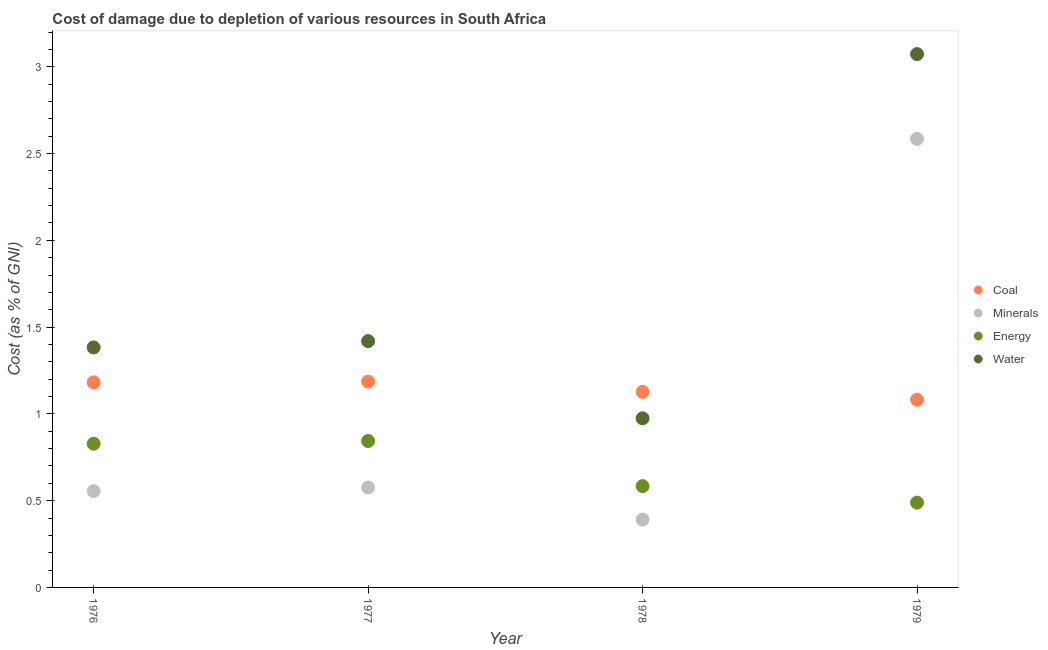Is the number of dotlines equal to the number of legend labels?
Provide a succinct answer. Yes. What is the cost of damage due to depletion of minerals in 1979?
Offer a very short reply. 2.58. Across all years, what is the maximum cost of damage due to depletion of energy?
Provide a succinct answer. 0.84. Across all years, what is the minimum cost of damage due to depletion of coal?
Provide a short and direct response. 1.08. In which year was the cost of damage due to depletion of coal maximum?
Make the answer very short. 1977. In which year was the cost of damage due to depletion of minerals minimum?
Your answer should be compact. 1978. What is the total cost of damage due to depletion of water in the graph?
Your response must be concise. 6.85. What is the difference between the cost of damage due to depletion of minerals in 1977 and that in 1978?
Your response must be concise. 0.18. What is the difference between the cost of damage due to depletion of coal in 1979 and the cost of damage due to depletion of minerals in 1977?
Your response must be concise. 0.51. What is the average cost of damage due to depletion of energy per year?
Provide a succinct answer. 0.69. In the year 1976, what is the difference between the cost of damage due to depletion of minerals and cost of damage due to depletion of coal?
Your answer should be very brief. -0.63. What is the ratio of the cost of damage due to depletion of minerals in 1976 to that in 1977?
Ensure brevity in your answer.  0.96. Is the cost of damage due to depletion of coal in 1978 less than that in 1979?
Provide a short and direct response. No. Is the difference between the cost of damage due to depletion of water in 1976 and 1977 greater than the difference between the cost of damage due to depletion of minerals in 1976 and 1977?
Offer a very short reply. No. What is the difference between the highest and the second highest cost of damage due to depletion of minerals?
Provide a succinct answer. 2.01. What is the difference between the highest and the lowest cost of damage due to depletion of water?
Keep it short and to the point. 2.1. In how many years, is the cost of damage due to depletion of water greater than the average cost of damage due to depletion of water taken over all years?
Provide a succinct answer. 1. Is it the case that in every year, the sum of the cost of damage due to depletion of minerals and cost of damage due to depletion of water is greater than the sum of cost of damage due to depletion of energy and cost of damage due to depletion of coal?
Give a very brief answer. Yes. Is it the case that in every year, the sum of the cost of damage due to depletion of coal and cost of damage due to depletion of minerals is greater than the cost of damage due to depletion of energy?
Provide a succinct answer. Yes. Does the cost of damage due to depletion of coal monotonically increase over the years?
Your answer should be very brief. No. Is the cost of damage due to depletion of coal strictly less than the cost of damage due to depletion of energy over the years?
Your response must be concise. No. How many dotlines are there?
Offer a very short reply. 4. Does the graph contain grids?
Provide a succinct answer. No. Where does the legend appear in the graph?
Offer a terse response. Center right. How many legend labels are there?
Your response must be concise. 4. What is the title of the graph?
Provide a succinct answer. Cost of damage due to depletion of various resources in South Africa . What is the label or title of the X-axis?
Provide a short and direct response. Year. What is the label or title of the Y-axis?
Give a very brief answer. Cost (as % of GNI). What is the Cost (as % of GNI) in Coal in 1976?
Your answer should be very brief. 1.18. What is the Cost (as % of GNI) of Minerals in 1976?
Keep it short and to the point. 0.55. What is the Cost (as % of GNI) in Energy in 1976?
Make the answer very short. 0.83. What is the Cost (as % of GNI) of Water in 1976?
Offer a terse response. 1.38. What is the Cost (as % of GNI) of Coal in 1977?
Give a very brief answer. 1.19. What is the Cost (as % of GNI) in Minerals in 1977?
Keep it short and to the point. 0.58. What is the Cost (as % of GNI) of Energy in 1977?
Keep it short and to the point. 0.84. What is the Cost (as % of GNI) in Water in 1977?
Ensure brevity in your answer.  1.42. What is the Cost (as % of GNI) in Coal in 1978?
Provide a short and direct response. 1.13. What is the Cost (as % of GNI) of Minerals in 1978?
Provide a succinct answer. 0.39. What is the Cost (as % of GNI) in Energy in 1978?
Provide a succinct answer. 0.58. What is the Cost (as % of GNI) of Water in 1978?
Your response must be concise. 0.97. What is the Cost (as % of GNI) in Coal in 1979?
Your answer should be compact. 1.08. What is the Cost (as % of GNI) of Minerals in 1979?
Provide a succinct answer. 2.58. What is the Cost (as % of GNI) in Energy in 1979?
Provide a succinct answer. 0.49. What is the Cost (as % of GNI) of Water in 1979?
Give a very brief answer. 3.07. Across all years, what is the maximum Cost (as % of GNI) of Coal?
Your answer should be very brief. 1.19. Across all years, what is the maximum Cost (as % of GNI) in Minerals?
Your answer should be very brief. 2.58. Across all years, what is the maximum Cost (as % of GNI) in Energy?
Offer a very short reply. 0.84. Across all years, what is the maximum Cost (as % of GNI) of Water?
Keep it short and to the point. 3.07. Across all years, what is the minimum Cost (as % of GNI) of Coal?
Your answer should be very brief. 1.08. Across all years, what is the minimum Cost (as % of GNI) of Minerals?
Offer a very short reply. 0.39. Across all years, what is the minimum Cost (as % of GNI) of Energy?
Provide a succinct answer. 0.49. Across all years, what is the minimum Cost (as % of GNI) in Water?
Ensure brevity in your answer.  0.97. What is the total Cost (as % of GNI) of Coal in the graph?
Your answer should be compact. 4.58. What is the total Cost (as % of GNI) in Minerals in the graph?
Offer a terse response. 4.11. What is the total Cost (as % of GNI) of Energy in the graph?
Provide a succinct answer. 2.74. What is the total Cost (as % of GNI) of Water in the graph?
Keep it short and to the point. 6.85. What is the difference between the Cost (as % of GNI) in Coal in 1976 and that in 1977?
Your response must be concise. -0. What is the difference between the Cost (as % of GNI) in Minerals in 1976 and that in 1977?
Offer a terse response. -0.02. What is the difference between the Cost (as % of GNI) of Energy in 1976 and that in 1977?
Your response must be concise. -0.02. What is the difference between the Cost (as % of GNI) of Water in 1976 and that in 1977?
Your answer should be compact. -0.04. What is the difference between the Cost (as % of GNI) of Coal in 1976 and that in 1978?
Offer a terse response. 0.05. What is the difference between the Cost (as % of GNI) in Minerals in 1976 and that in 1978?
Offer a very short reply. 0.16. What is the difference between the Cost (as % of GNI) of Energy in 1976 and that in 1978?
Provide a short and direct response. 0.24. What is the difference between the Cost (as % of GNI) of Water in 1976 and that in 1978?
Make the answer very short. 0.41. What is the difference between the Cost (as % of GNI) in Coal in 1976 and that in 1979?
Provide a short and direct response. 0.1. What is the difference between the Cost (as % of GNI) in Minerals in 1976 and that in 1979?
Offer a terse response. -2.03. What is the difference between the Cost (as % of GNI) of Energy in 1976 and that in 1979?
Provide a short and direct response. 0.34. What is the difference between the Cost (as % of GNI) of Water in 1976 and that in 1979?
Provide a short and direct response. -1.69. What is the difference between the Cost (as % of GNI) in Coal in 1977 and that in 1978?
Provide a short and direct response. 0.06. What is the difference between the Cost (as % of GNI) of Minerals in 1977 and that in 1978?
Offer a very short reply. 0.18. What is the difference between the Cost (as % of GNI) in Energy in 1977 and that in 1978?
Your answer should be very brief. 0.26. What is the difference between the Cost (as % of GNI) in Water in 1977 and that in 1978?
Your response must be concise. 0.44. What is the difference between the Cost (as % of GNI) in Coal in 1977 and that in 1979?
Ensure brevity in your answer.  0.1. What is the difference between the Cost (as % of GNI) of Minerals in 1977 and that in 1979?
Your answer should be compact. -2.01. What is the difference between the Cost (as % of GNI) in Energy in 1977 and that in 1979?
Your answer should be compact. 0.35. What is the difference between the Cost (as % of GNI) in Water in 1977 and that in 1979?
Provide a short and direct response. -1.65. What is the difference between the Cost (as % of GNI) of Coal in 1978 and that in 1979?
Keep it short and to the point. 0.04. What is the difference between the Cost (as % of GNI) in Minerals in 1978 and that in 1979?
Make the answer very short. -2.19. What is the difference between the Cost (as % of GNI) of Energy in 1978 and that in 1979?
Your answer should be very brief. 0.1. What is the difference between the Cost (as % of GNI) in Water in 1978 and that in 1979?
Provide a succinct answer. -2.1. What is the difference between the Cost (as % of GNI) in Coal in 1976 and the Cost (as % of GNI) in Minerals in 1977?
Your response must be concise. 0.61. What is the difference between the Cost (as % of GNI) of Coal in 1976 and the Cost (as % of GNI) of Energy in 1977?
Provide a short and direct response. 0.34. What is the difference between the Cost (as % of GNI) in Coal in 1976 and the Cost (as % of GNI) in Water in 1977?
Provide a short and direct response. -0.24. What is the difference between the Cost (as % of GNI) in Minerals in 1976 and the Cost (as % of GNI) in Energy in 1977?
Keep it short and to the point. -0.29. What is the difference between the Cost (as % of GNI) in Minerals in 1976 and the Cost (as % of GNI) in Water in 1977?
Your answer should be compact. -0.86. What is the difference between the Cost (as % of GNI) in Energy in 1976 and the Cost (as % of GNI) in Water in 1977?
Provide a succinct answer. -0.59. What is the difference between the Cost (as % of GNI) of Coal in 1976 and the Cost (as % of GNI) of Minerals in 1978?
Keep it short and to the point. 0.79. What is the difference between the Cost (as % of GNI) of Coal in 1976 and the Cost (as % of GNI) of Energy in 1978?
Provide a succinct answer. 0.6. What is the difference between the Cost (as % of GNI) in Coal in 1976 and the Cost (as % of GNI) in Water in 1978?
Give a very brief answer. 0.21. What is the difference between the Cost (as % of GNI) of Minerals in 1976 and the Cost (as % of GNI) of Energy in 1978?
Your answer should be very brief. -0.03. What is the difference between the Cost (as % of GNI) in Minerals in 1976 and the Cost (as % of GNI) in Water in 1978?
Make the answer very short. -0.42. What is the difference between the Cost (as % of GNI) of Energy in 1976 and the Cost (as % of GNI) of Water in 1978?
Ensure brevity in your answer.  -0.15. What is the difference between the Cost (as % of GNI) of Coal in 1976 and the Cost (as % of GNI) of Minerals in 1979?
Keep it short and to the point. -1.4. What is the difference between the Cost (as % of GNI) of Coal in 1976 and the Cost (as % of GNI) of Energy in 1979?
Give a very brief answer. 0.69. What is the difference between the Cost (as % of GNI) in Coal in 1976 and the Cost (as % of GNI) in Water in 1979?
Your answer should be very brief. -1.89. What is the difference between the Cost (as % of GNI) of Minerals in 1976 and the Cost (as % of GNI) of Energy in 1979?
Provide a short and direct response. 0.07. What is the difference between the Cost (as % of GNI) in Minerals in 1976 and the Cost (as % of GNI) in Water in 1979?
Keep it short and to the point. -2.52. What is the difference between the Cost (as % of GNI) in Energy in 1976 and the Cost (as % of GNI) in Water in 1979?
Provide a succinct answer. -2.24. What is the difference between the Cost (as % of GNI) of Coal in 1977 and the Cost (as % of GNI) of Minerals in 1978?
Your answer should be compact. 0.8. What is the difference between the Cost (as % of GNI) of Coal in 1977 and the Cost (as % of GNI) of Energy in 1978?
Your answer should be compact. 0.6. What is the difference between the Cost (as % of GNI) in Coal in 1977 and the Cost (as % of GNI) in Water in 1978?
Provide a succinct answer. 0.21. What is the difference between the Cost (as % of GNI) in Minerals in 1977 and the Cost (as % of GNI) in Energy in 1978?
Ensure brevity in your answer.  -0.01. What is the difference between the Cost (as % of GNI) of Minerals in 1977 and the Cost (as % of GNI) of Water in 1978?
Offer a terse response. -0.4. What is the difference between the Cost (as % of GNI) of Energy in 1977 and the Cost (as % of GNI) of Water in 1978?
Keep it short and to the point. -0.13. What is the difference between the Cost (as % of GNI) of Coal in 1977 and the Cost (as % of GNI) of Minerals in 1979?
Your answer should be very brief. -1.4. What is the difference between the Cost (as % of GNI) in Coal in 1977 and the Cost (as % of GNI) in Energy in 1979?
Your answer should be very brief. 0.7. What is the difference between the Cost (as % of GNI) of Coal in 1977 and the Cost (as % of GNI) of Water in 1979?
Provide a succinct answer. -1.89. What is the difference between the Cost (as % of GNI) of Minerals in 1977 and the Cost (as % of GNI) of Energy in 1979?
Make the answer very short. 0.09. What is the difference between the Cost (as % of GNI) in Minerals in 1977 and the Cost (as % of GNI) in Water in 1979?
Make the answer very short. -2.5. What is the difference between the Cost (as % of GNI) of Energy in 1977 and the Cost (as % of GNI) of Water in 1979?
Offer a very short reply. -2.23. What is the difference between the Cost (as % of GNI) in Coal in 1978 and the Cost (as % of GNI) in Minerals in 1979?
Give a very brief answer. -1.46. What is the difference between the Cost (as % of GNI) of Coal in 1978 and the Cost (as % of GNI) of Energy in 1979?
Your answer should be very brief. 0.64. What is the difference between the Cost (as % of GNI) of Coal in 1978 and the Cost (as % of GNI) of Water in 1979?
Give a very brief answer. -1.95. What is the difference between the Cost (as % of GNI) of Minerals in 1978 and the Cost (as % of GNI) of Energy in 1979?
Your answer should be very brief. -0.1. What is the difference between the Cost (as % of GNI) in Minerals in 1978 and the Cost (as % of GNI) in Water in 1979?
Keep it short and to the point. -2.68. What is the difference between the Cost (as % of GNI) in Energy in 1978 and the Cost (as % of GNI) in Water in 1979?
Your response must be concise. -2.49. What is the average Cost (as % of GNI) in Coal per year?
Offer a terse response. 1.14. What is the average Cost (as % of GNI) in Minerals per year?
Offer a very short reply. 1.03. What is the average Cost (as % of GNI) in Energy per year?
Your answer should be very brief. 0.69. What is the average Cost (as % of GNI) in Water per year?
Keep it short and to the point. 1.71. In the year 1976, what is the difference between the Cost (as % of GNI) of Coal and Cost (as % of GNI) of Minerals?
Offer a very short reply. 0.63. In the year 1976, what is the difference between the Cost (as % of GNI) in Coal and Cost (as % of GNI) in Energy?
Your answer should be very brief. 0.35. In the year 1976, what is the difference between the Cost (as % of GNI) of Coal and Cost (as % of GNI) of Water?
Provide a succinct answer. -0.2. In the year 1976, what is the difference between the Cost (as % of GNI) in Minerals and Cost (as % of GNI) in Energy?
Your answer should be very brief. -0.27. In the year 1976, what is the difference between the Cost (as % of GNI) of Minerals and Cost (as % of GNI) of Water?
Provide a short and direct response. -0.83. In the year 1976, what is the difference between the Cost (as % of GNI) of Energy and Cost (as % of GNI) of Water?
Keep it short and to the point. -0.55. In the year 1977, what is the difference between the Cost (as % of GNI) in Coal and Cost (as % of GNI) in Minerals?
Your response must be concise. 0.61. In the year 1977, what is the difference between the Cost (as % of GNI) of Coal and Cost (as % of GNI) of Energy?
Your response must be concise. 0.34. In the year 1977, what is the difference between the Cost (as % of GNI) of Coal and Cost (as % of GNI) of Water?
Your response must be concise. -0.23. In the year 1977, what is the difference between the Cost (as % of GNI) of Minerals and Cost (as % of GNI) of Energy?
Provide a short and direct response. -0.27. In the year 1977, what is the difference between the Cost (as % of GNI) in Minerals and Cost (as % of GNI) in Water?
Offer a very short reply. -0.84. In the year 1977, what is the difference between the Cost (as % of GNI) of Energy and Cost (as % of GNI) of Water?
Offer a very short reply. -0.58. In the year 1978, what is the difference between the Cost (as % of GNI) of Coal and Cost (as % of GNI) of Minerals?
Provide a succinct answer. 0.74. In the year 1978, what is the difference between the Cost (as % of GNI) of Coal and Cost (as % of GNI) of Energy?
Ensure brevity in your answer.  0.54. In the year 1978, what is the difference between the Cost (as % of GNI) in Coal and Cost (as % of GNI) in Water?
Offer a very short reply. 0.15. In the year 1978, what is the difference between the Cost (as % of GNI) of Minerals and Cost (as % of GNI) of Energy?
Provide a succinct answer. -0.19. In the year 1978, what is the difference between the Cost (as % of GNI) of Minerals and Cost (as % of GNI) of Water?
Your answer should be compact. -0.58. In the year 1978, what is the difference between the Cost (as % of GNI) in Energy and Cost (as % of GNI) in Water?
Ensure brevity in your answer.  -0.39. In the year 1979, what is the difference between the Cost (as % of GNI) of Coal and Cost (as % of GNI) of Minerals?
Your response must be concise. -1.5. In the year 1979, what is the difference between the Cost (as % of GNI) of Coal and Cost (as % of GNI) of Energy?
Your response must be concise. 0.59. In the year 1979, what is the difference between the Cost (as % of GNI) of Coal and Cost (as % of GNI) of Water?
Provide a succinct answer. -1.99. In the year 1979, what is the difference between the Cost (as % of GNI) in Minerals and Cost (as % of GNI) in Energy?
Ensure brevity in your answer.  2.1. In the year 1979, what is the difference between the Cost (as % of GNI) in Minerals and Cost (as % of GNI) in Water?
Provide a short and direct response. -0.49. In the year 1979, what is the difference between the Cost (as % of GNI) of Energy and Cost (as % of GNI) of Water?
Make the answer very short. -2.58. What is the ratio of the Cost (as % of GNI) in Coal in 1976 to that in 1977?
Provide a short and direct response. 1. What is the ratio of the Cost (as % of GNI) in Minerals in 1976 to that in 1977?
Give a very brief answer. 0.96. What is the ratio of the Cost (as % of GNI) of Energy in 1976 to that in 1977?
Offer a terse response. 0.98. What is the ratio of the Cost (as % of GNI) in Water in 1976 to that in 1977?
Your answer should be very brief. 0.97. What is the ratio of the Cost (as % of GNI) of Coal in 1976 to that in 1978?
Give a very brief answer. 1.05. What is the ratio of the Cost (as % of GNI) in Minerals in 1976 to that in 1978?
Your answer should be very brief. 1.42. What is the ratio of the Cost (as % of GNI) of Energy in 1976 to that in 1978?
Make the answer very short. 1.42. What is the ratio of the Cost (as % of GNI) in Water in 1976 to that in 1978?
Keep it short and to the point. 1.42. What is the ratio of the Cost (as % of GNI) in Coal in 1976 to that in 1979?
Provide a short and direct response. 1.09. What is the ratio of the Cost (as % of GNI) in Minerals in 1976 to that in 1979?
Provide a succinct answer. 0.21. What is the ratio of the Cost (as % of GNI) in Energy in 1976 to that in 1979?
Make the answer very short. 1.69. What is the ratio of the Cost (as % of GNI) of Water in 1976 to that in 1979?
Offer a terse response. 0.45. What is the ratio of the Cost (as % of GNI) of Coal in 1977 to that in 1978?
Provide a succinct answer. 1.05. What is the ratio of the Cost (as % of GNI) in Minerals in 1977 to that in 1978?
Give a very brief answer. 1.47. What is the ratio of the Cost (as % of GNI) of Energy in 1977 to that in 1978?
Make the answer very short. 1.45. What is the ratio of the Cost (as % of GNI) in Water in 1977 to that in 1978?
Your response must be concise. 1.46. What is the ratio of the Cost (as % of GNI) of Coal in 1977 to that in 1979?
Make the answer very short. 1.1. What is the ratio of the Cost (as % of GNI) of Minerals in 1977 to that in 1979?
Ensure brevity in your answer.  0.22. What is the ratio of the Cost (as % of GNI) in Energy in 1977 to that in 1979?
Make the answer very short. 1.73. What is the ratio of the Cost (as % of GNI) of Water in 1977 to that in 1979?
Keep it short and to the point. 0.46. What is the ratio of the Cost (as % of GNI) of Coal in 1978 to that in 1979?
Provide a short and direct response. 1.04. What is the ratio of the Cost (as % of GNI) in Minerals in 1978 to that in 1979?
Ensure brevity in your answer.  0.15. What is the ratio of the Cost (as % of GNI) of Energy in 1978 to that in 1979?
Ensure brevity in your answer.  1.19. What is the ratio of the Cost (as % of GNI) in Water in 1978 to that in 1979?
Offer a terse response. 0.32. What is the difference between the highest and the second highest Cost (as % of GNI) in Coal?
Offer a very short reply. 0. What is the difference between the highest and the second highest Cost (as % of GNI) in Minerals?
Your answer should be very brief. 2.01. What is the difference between the highest and the second highest Cost (as % of GNI) in Energy?
Your answer should be very brief. 0.02. What is the difference between the highest and the second highest Cost (as % of GNI) in Water?
Provide a succinct answer. 1.65. What is the difference between the highest and the lowest Cost (as % of GNI) in Coal?
Make the answer very short. 0.1. What is the difference between the highest and the lowest Cost (as % of GNI) in Minerals?
Give a very brief answer. 2.19. What is the difference between the highest and the lowest Cost (as % of GNI) in Energy?
Provide a succinct answer. 0.35. What is the difference between the highest and the lowest Cost (as % of GNI) in Water?
Make the answer very short. 2.1. 